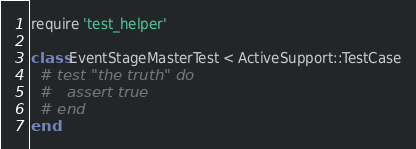<code> <loc_0><loc_0><loc_500><loc_500><_Ruby_>require 'test_helper'

class EventStageMasterTest < ActiveSupport::TestCase
  # test "the truth" do
  #   assert true
  # end
end
</code> 